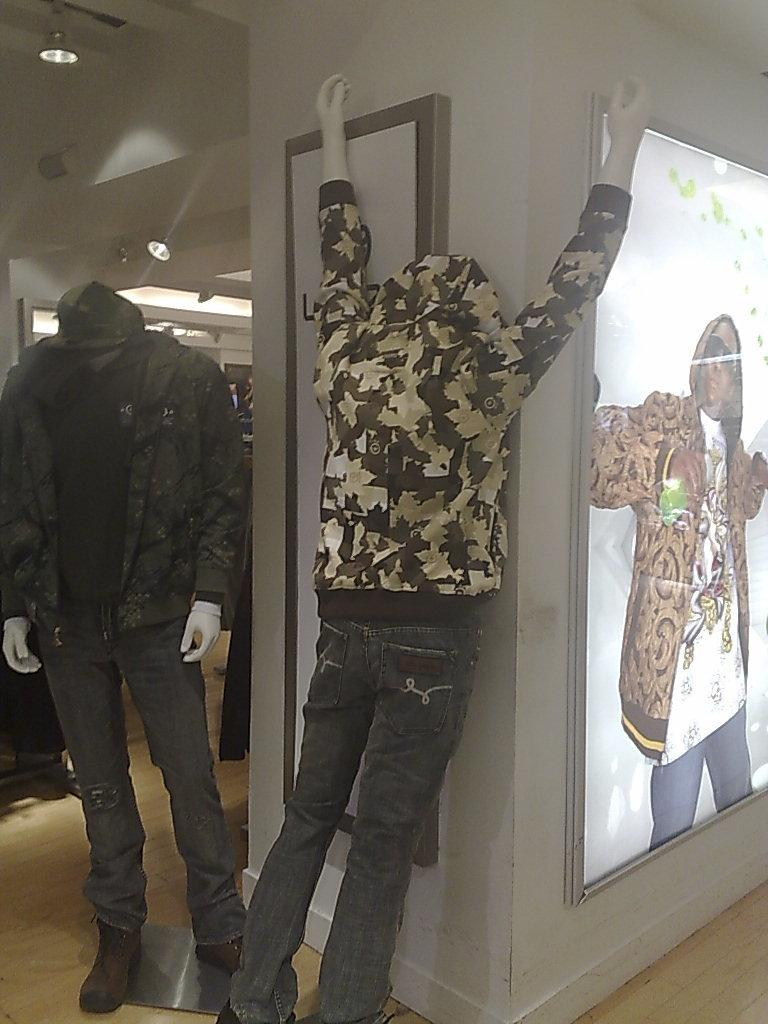How many mannequins are in the image? There are two mannequins in the image. What are the mannequins wearing? The mannequins are wearing dresses. What can be seen on the wall in the background? There are photo frames on the wall in the background. What else is visible in the background? There are lights visible in the background. What type of bun is the dad holding in the image? There is no dad or bun present in the image; it features two mannequins wearing dresses and other elements in the background. 